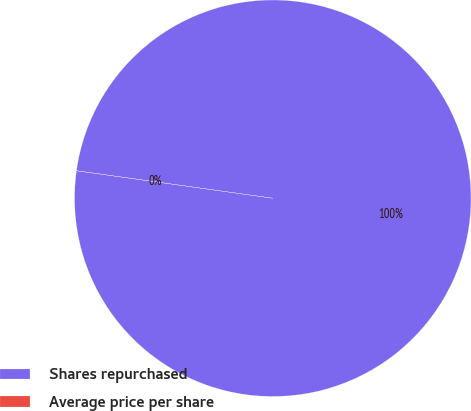Convert chart to OTSL. <chart><loc_0><loc_0><loc_500><loc_500><pie_chart><fcel>Shares repurchased<fcel>Average price per share<nl><fcel>99.99%<fcel>0.01%<nl></chart> 